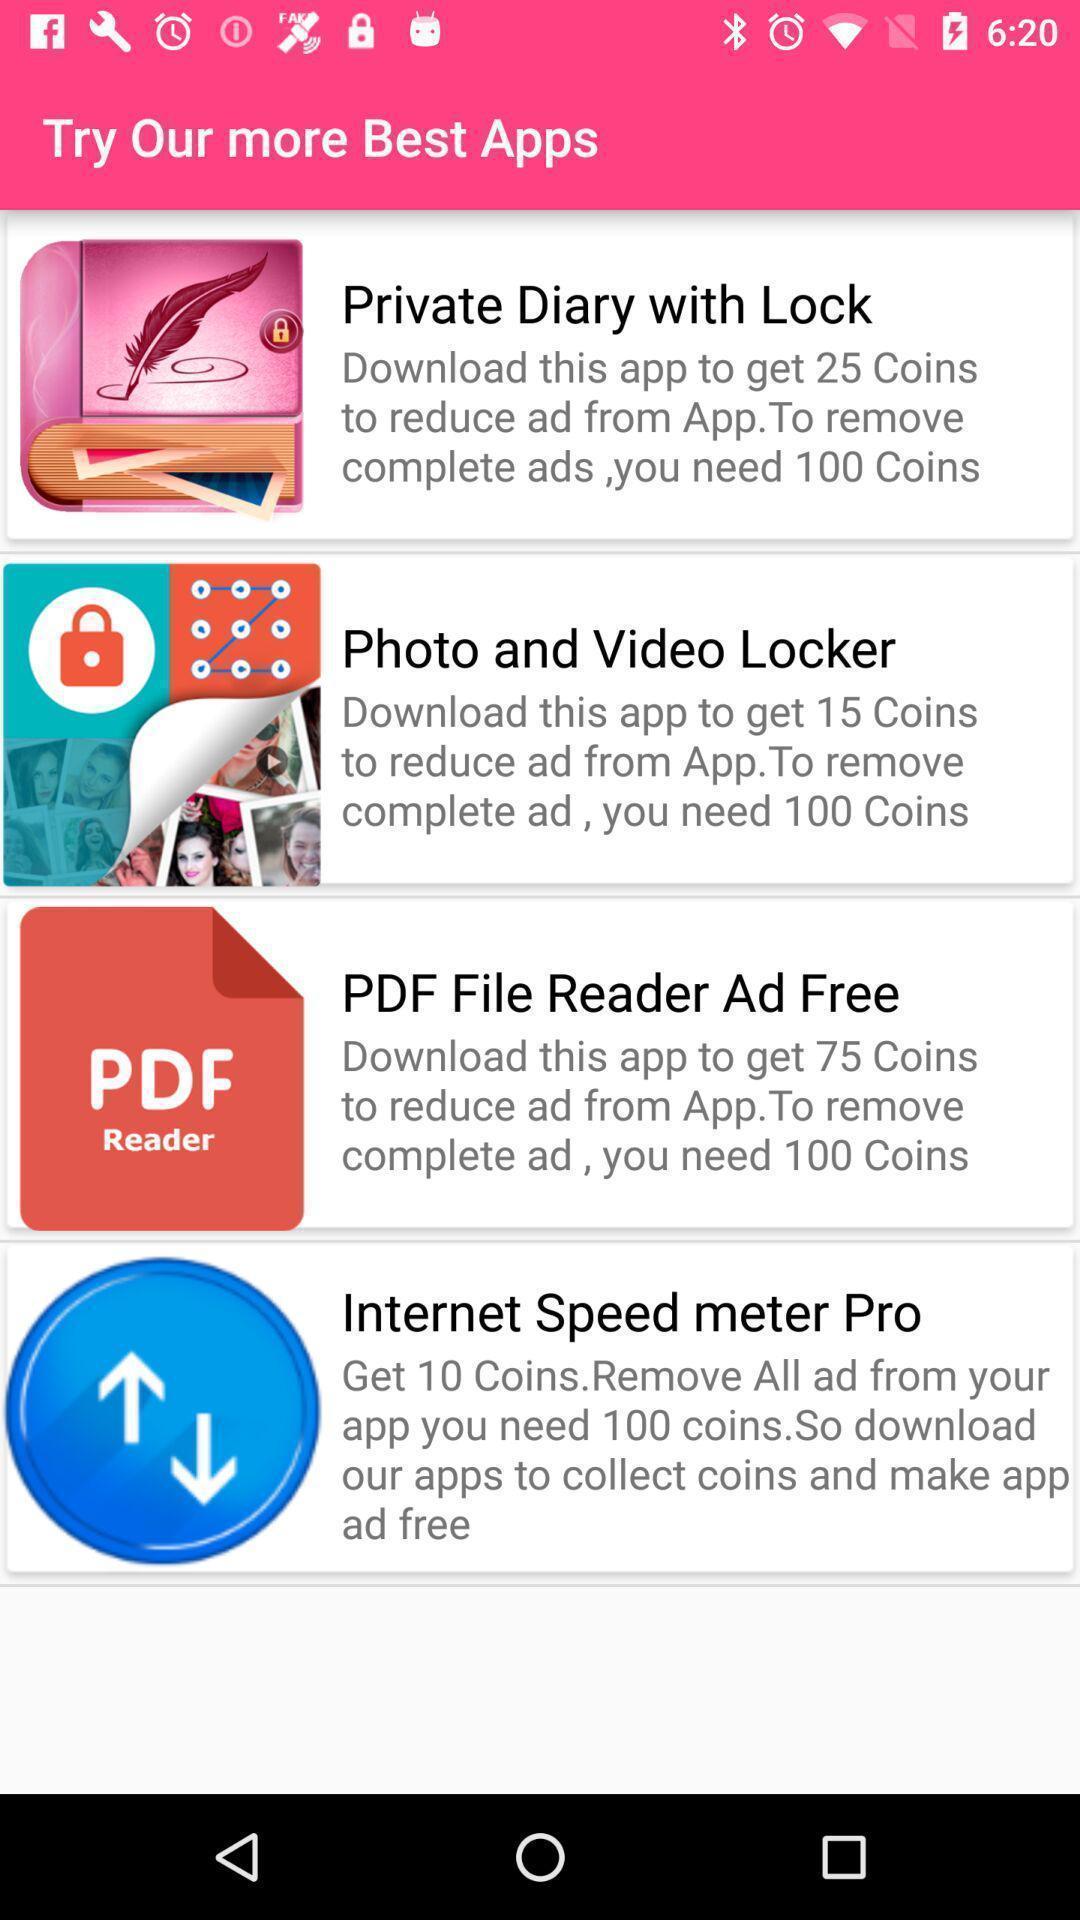Tell me what you see in this picture. Page displaying the list of different apps. 